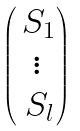Convert formula to latex. <formula><loc_0><loc_0><loc_500><loc_500>\begin{pmatrix} \, S _ { 1 } \\ \vdots \\ \, S _ { l } \end{pmatrix}</formula> 